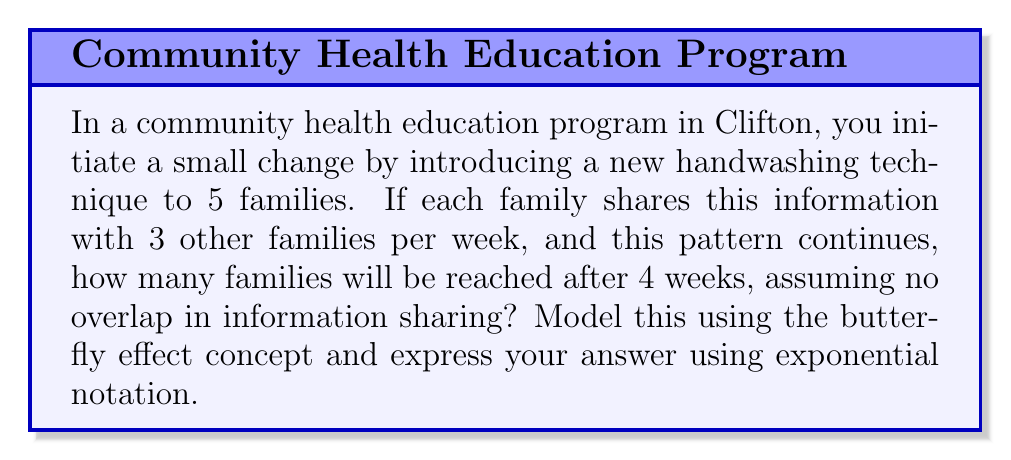Teach me how to tackle this problem. Let's approach this step-by-step using the butterfly effect concept, where a small initial change can lead to significant outcomes over time:

1) Initial state: 5 families are informed.

2) Week 1:
   Each of the 5 families informs 3 new families.
   New families reached: $5 * 3 = 15$
   Total families: $5 + 15 = 20$

3) Week 2:
   Each of the 15 new families from Week 1 informs 3 new families.
   New families reached: $15 * 3 = 45$
   Total families: $20 + 45 = 65$

4) Week 3:
   Each of the 45 new families from Week 2 informs 3 new families.
   New families reached: $45 * 3 = 135$
   Total families: $65 + 135 = 200$

5) Week 4:
   Each of the 135 new families from Week 3 informs 3 new families.
   New families reached: $135 * 3 = 405$
   Total families: $200 + 405 = 605$

6) We can observe a pattern forming:
   $$5 * (1 + 3 + 3^2 + 3^3 + 3^4)$$

7) This is a geometric series with first term $a=1$ and common ratio $r=3$:
   $$S_n = a\frac{1-r^n}{1-r}, \text{ where } n=5$$

8) Substituting the values:
   $$5 * \frac{1-3^5}{1-3} = 5 * \frac{1-243}{-2} = 5 * 121 = 605$$

9) We can express this in exponential notation as:
   $$5 * (3^5 - 1) / 2 = 5 * 3^5 / 2 - 5/2 = 5 * 3^5 / 2 - 2.5$$
Answer: $5 * 3^5 / 2 - 2.5$ 